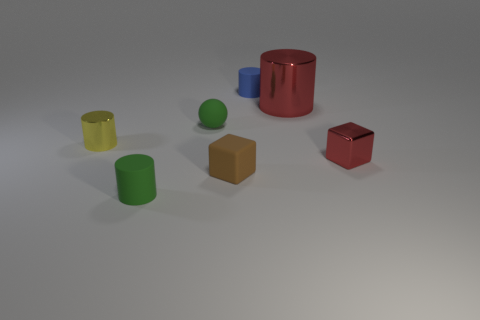Subtract all tiny cylinders. How many cylinders are left? 1 Add 2 large brown spheres. How many objects exist? 9 Subtract all blue cylinders. How many cylinders are left? 3 Subtract all spheres. How many objects are left? 6 Subtract 0 blue balls. How many objects are left? 7 Subtract all brown cylinders. Subtract all gray cubes. How many cylinders are left? 4 Subtract all tiny brown rubber things. Subtract all tiny yellow cylinders. How many objects are left? 5 Add 2 small blue rubber cylinders. How many small blue rubber cylinders are left? 3 Add 2 tiny cyan things. How many tiny cyan things exist? 2 